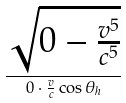<formula> <loc_0><loc_0><loc_500><loc_500>\frac { \sqrt { 0 - \frac { v ^ { 5 } } { c ^ { 5 } } } } { 0 \cdot \frac { v } { c } \cos \theta _ { h } }</formula> 